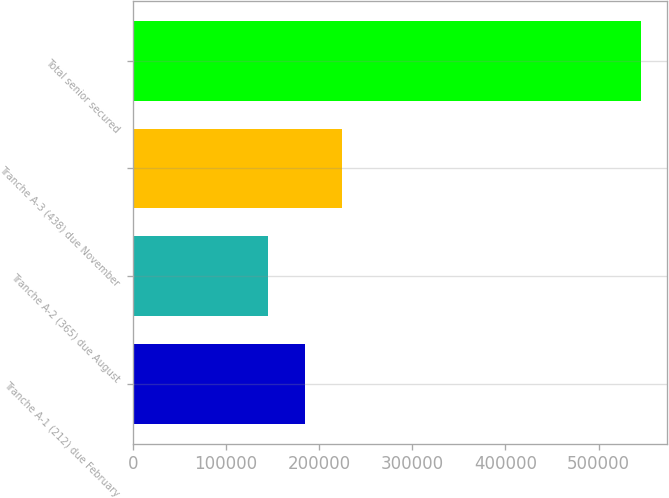Convert chart to OTSL. <chart><loc_0><loc_0><loc_500><loc_500><bar_chart><fcel>Tranche A-1 (212) due February<fcel>Tranche A-2 (365) due August<fcel>Tranche A-3 (438) due November<fcel>Total senior secured<nl><fcel>184910<fcel>144800<fcel>225020<fcel>545900<nl></chart> 